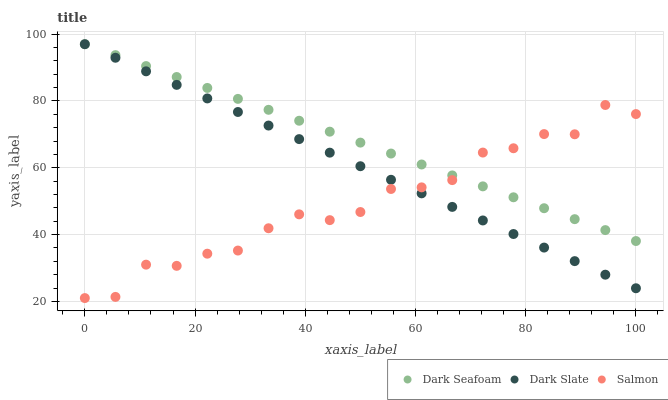Does Salmon have the minimum area under the curve?
Answer yes or no. Yes. Does Dark Seafoam have the maximum area under the curve?
Answer yes or no. Yes. Does Dark Seafoam have the minimum area under the curve?
Answer yes or no. No. Does Salmon have the maximum area under the curve?
Answer yes or no. No. Is Dark Slate the smoothest?
Answer yes or no. Yes. Is Salmon the roughest?
Answer yes or no. Yes. Is Dark Seafoam the smoothest?
Answer yes or no. No. Is Dark Seafoam the roughest?
Answer yes or no. No. Does Salmon have the lowest value?
Answer yes or no. Yes. Does Dark Seafoam have the lowest value?
Answer yes or no. No. Does Dark Seafoam have the highest value?
Answer yes or no. Yes. Does Salmon have the highest value?
Answer yes or no. No. Does Salmon intersect Dark Seafoam?
Answer yes or no. Yes. Is Salmon less than Dark Seafoam?
Answer yes or no. No. Is Salmon greater than Dark Seafoam?
Answer yes or no. No. 